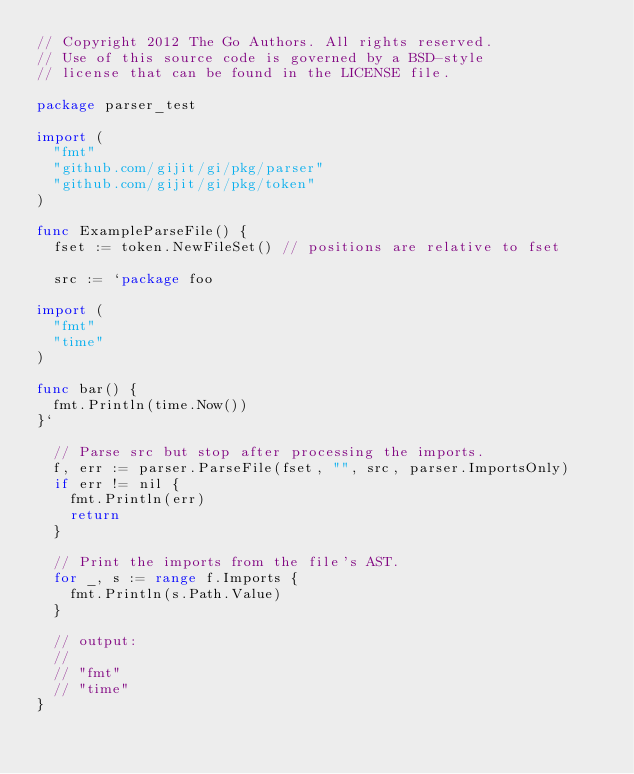<code> <loc_0><loc_0><loc_500><loc_500><_Go_>// Copyright 2012 The Go Authors. All rights reserved.
// Use of this source code is governed by a BSD-style
// license that can be found in the LICENSE file.

package parser_test

import (
	"fmt"
	"github.com/gijit/gi/pkg/parser"
	"github.com/gijit/gi/pkg/token"
)

func ExampleParseFile() {
	fset := token.NewFileSet() // positions are relative to fset

	src := `package foo

import (
	"fmt"
	"time"
)

func bar() {
	fmt.Println(time.Now())
}`

	// Parse src but stop after processing the imports.
	f, err := parser.ParseFile(fset, "", src, parser.ImportsOnly)
	if err != nil {
		fmt.Println(err)
		return
	}

	// Print the imports from the file's AST.
	for _, s := range f.Imports {
		fmt.Println(s.Path.Value)
	}

	// output:
	//
	// "fmt"
	// "time"
}
</code> 